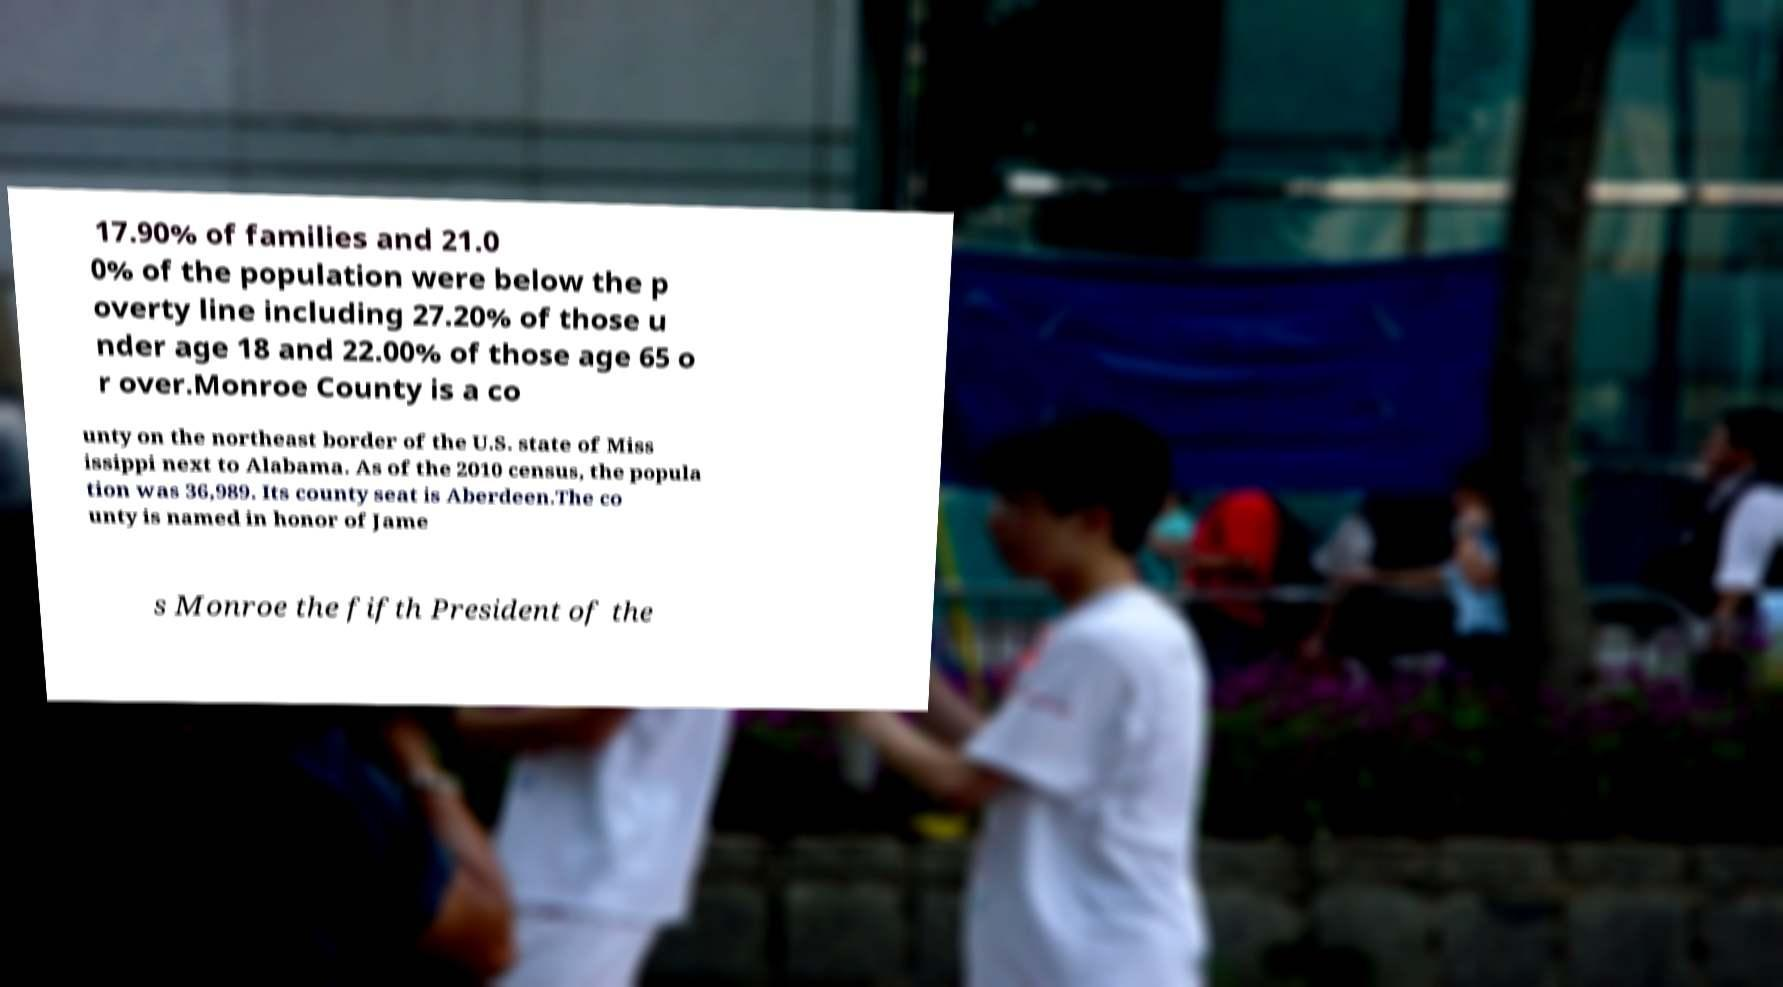There's text embedded in this image that I need extracted. Can you transcribe it verbatim? 17.90% of families and 21.0 0% of the population were below the p overty line including 27.20% of those u nder age 18 and 22.00% of those age 65 o r over.Monroe County is a co unty on the northeast border of the U.S. state of Miss issippi next to Alabama. As of the 2010 census, the popula tion was 36,989. Its county seat is Aberdeen.The co unty is named in honor of Jame s Monroe the fifth President of the 